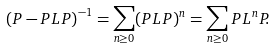<formula> <loc_0><loc_0><loc_500><loc_500>\left ( P - P L P \right ) ^ { - 1 } = \sum _ { n \geq 0 } ( P L P ) ^ { n } = \sum _ { n \geq 0 } P L ^ { n } P .</formula> 